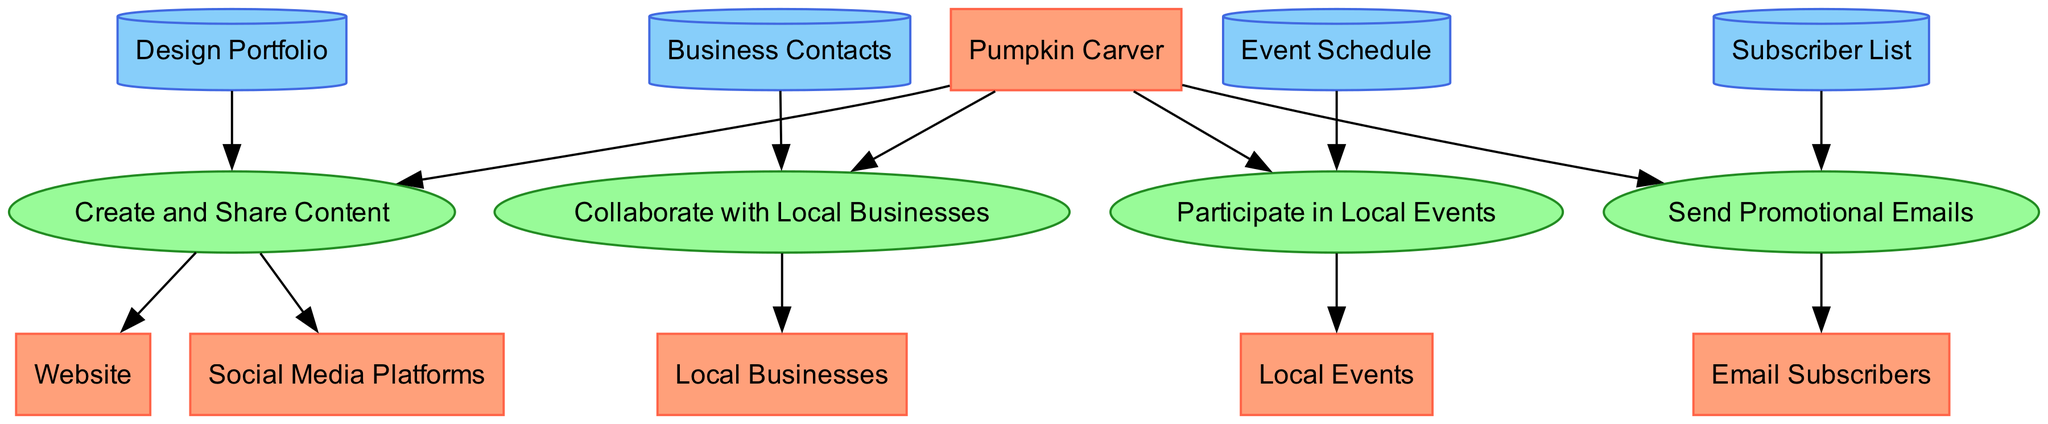What is the primary role depicted in the diagram? The node labeled "Pumpkin Carver" represents the primary role in the diagram. It's the central entity in the data flow, showcasing the main actor responsible for creating pumpkin designs.
Answer: Pumpkin Carver How many processes are illustrated in this diagram? The diagram features four distinct processes: "Create and Share Content," "Collaborate with Local Businesses," "Participate in Local Events," and "Send Promotional Emails." By counting these processes, we arrive at the number four.
Answer: 4 Which data store is related to the "Collaborate with Local Businesses" process? The process "Collaborate with Local Businesses" has an edge leading to the data store labeled "Business Contacts." It indicates that this process utilizes contacts from local businesses for collaboration.
Answer: Business Contacts What do "Email Subscribers" receive from the "Send Promotional Emails" process? The edge from "Send Promotional Emails" to "Email Subscribers" suggests that promotional content, such as newsletters and events, is sent to these subscribers within the context of the diagram.
Answer: Promotional content How many total edges connect the nodes in this diagram? To find the total edges, we count each connection between the nodes. The diagram shows a total of ten edges connecting various entities, processes, and data stores.
Answer: 10 Which two processes are directly linked to the "Pumpkin Carver"? The processes "Collaborate with Local Businesses" and "Participate in Local Events" both contain edges that directly connect back to the "Pumpkin Carver," showing these actions initiated by the pumpkin carver.
Answer: Collaborate with Local Businesses and Participate in Local Events What is the purpose of "Design Portfolio" in the diagram? The "Design Portfolio" is a data store that is connected to the process "Create and Share Content." This indicates that the portfolio is utilized to source designs and showcase them on various platforms.
Answer: Source designs Which platform involves sharing content created by the pumpkin carver? The "Social Media Platforms" node is directly connected to the process "Create and Share Content," indicating it is one of the means through which the carver shares their designs.
Answer: Social Media Platforms What happens after the "Participate in Local Events" process? The process "Participate in Local Events" leads to the "Local Events" node, which means that after participating, the outcomes or showcasing occur at local events.
Answer: Showcasing at Local Events 